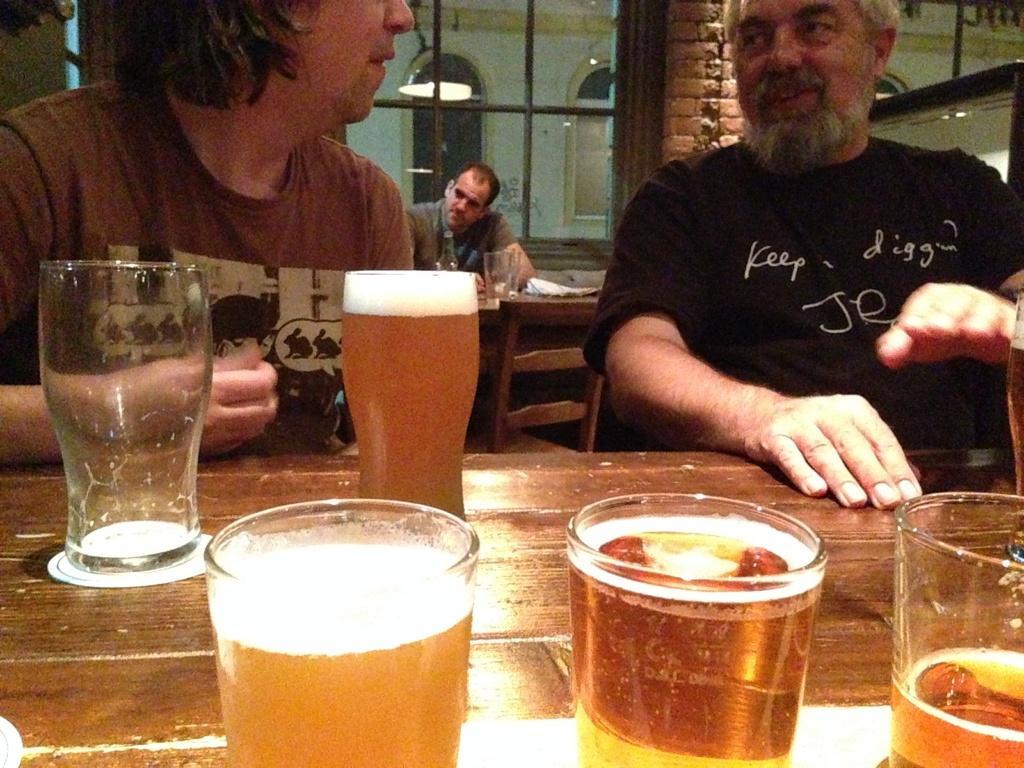Please provide a concise description of this image. This is a picture where we have three people and they are sitting on the chairs in front of a table where we have some glasses and drink in it. 